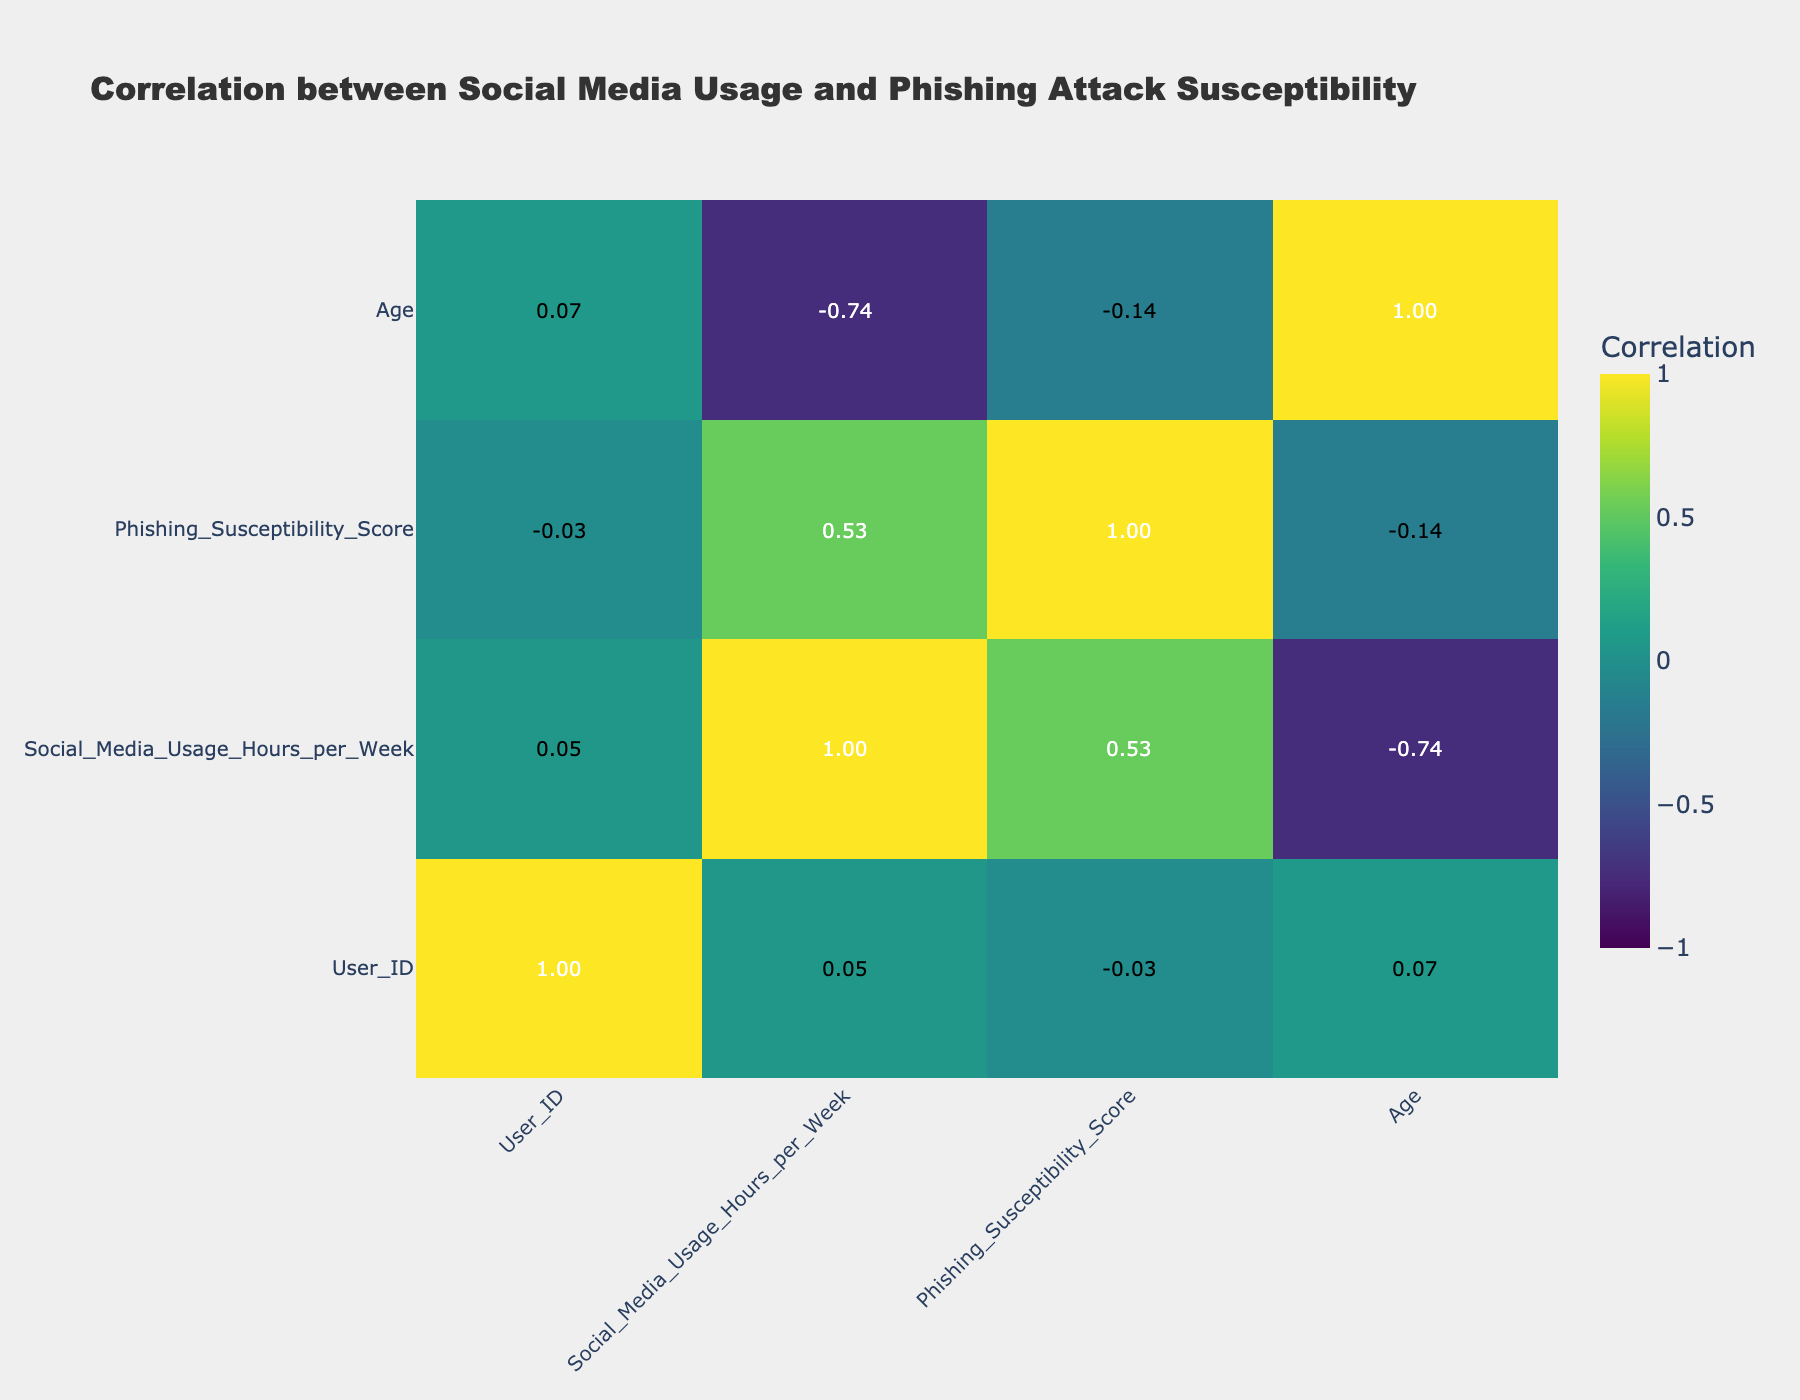What is the correlation coefficient between social media usage and phishing susceptibility? The correlation coefficient can be found in the table where the row for "Social_Media_Usage_Hours_per_Week" intersects with the column for "Phishing_Susceptibility_Score." From the table, the value is -0.15.
Answer: -0.15 Which user has the highest phishing susceptibility score? By scanning through the "Phishing_Susceptibility_Score" column, the highest score is 10, found in User 6.
Answer: User 6 Is there a user who utilized social media for 5 hours per week and had a phishing susceptibility score of 7? Looking through the table, User 10 matches the criteria with 5 hours/week of social media usage and a score of 7.
Answer: Yes What is the average phishing susceptibility score for users who have received internet safety training? By filtering the data for users who received internet safety training (User 1, User 3, User 5, User 9, User 10), the scores are 7, 5, 6, 9, and 7. The total sum is 34 and there are 5 users, so the average is 34/5 which equals 6.8.
Answer: 6.8 Is phishing susceptibility higher on average for users with a Bachelor’s degree than for users with a High School education? To compare, identify users with a Bachelor’s degree (User 1, User 4, User 7) have scores of 7, 8, and 4, respectively, giving an average of (7+8+4)/3 = 6.33. For High School users, User 2 and User 6 have scores of 9 and 10, averaging (9+10)/2 = 9.5. Since 6.33 < 9.5, the answer is no.
Answer: No How many users have a social media usage of more than 30 hours per week and a phishing susceptibility score of 8 or higher? Users who fit this criteria are User 4 (40 hours, 8 score) and User 6 (50 hours, 10 score), which gives a total count of 2 users.
Answer: 2 What is the difference between the highest and lowest phishing susceptibility scores among users? Reviewing the table, the highest score is 10 (User 6) and the lowest is 4 (User 7). The difference is calculated as 10 - 4 = 6.
Answer: 6 Which education level has the lowest average phishing susceptibility score? We can categorize the users by education level and find the averages: Bachelor's (7 + 8 + 4 = 19, 3 users) = 6.33, High School (9 + 10 = 19, 2 users) = 9.5, Master's (5 + 7 = 12, 2 users) = 6. The lowest average is Bachelor's degree at 6.33.
Answer: Bachelor's 